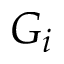<formula> <loc_0><loc_0><loc_500><loc_500>G _ { i }</formula> 